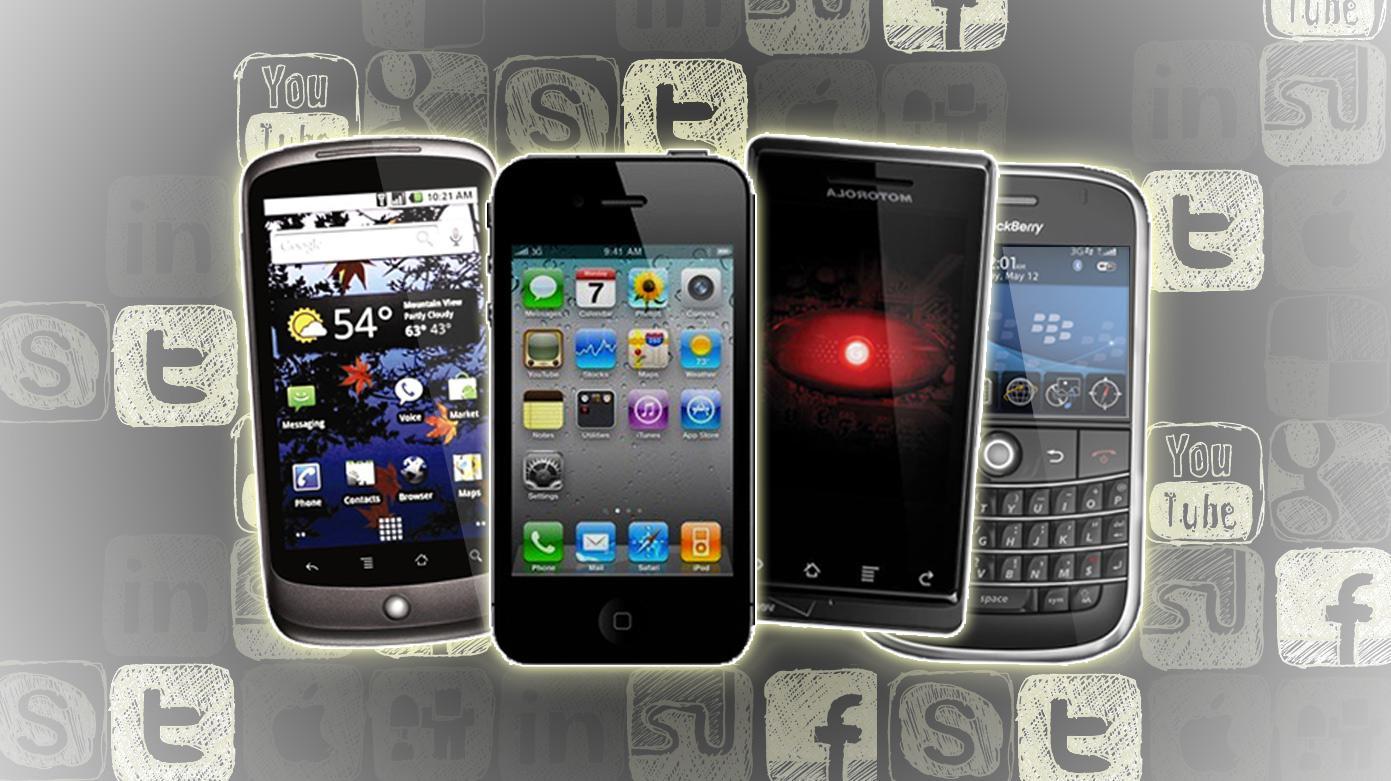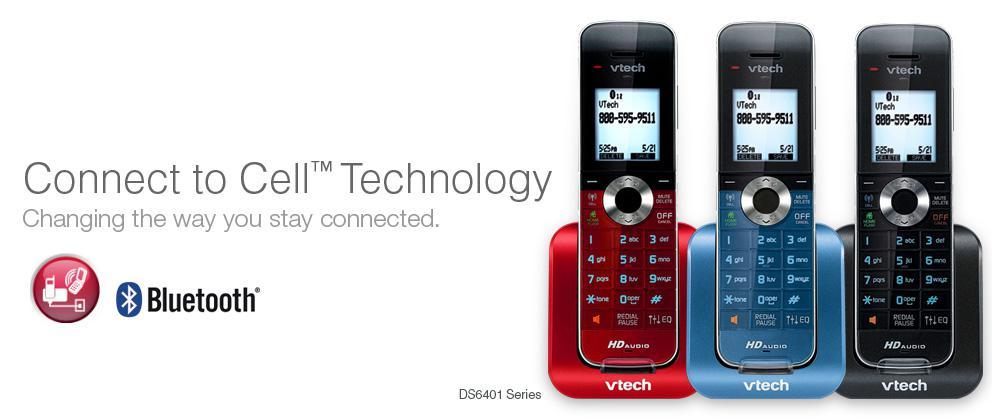The first image is the image on the left, the second image is the image on the right. Analyze the images presented: Is the assertion "There is a non smart phone in a charger." valid? Answer yes or no. Yes. The first image is the image on the left, the second image is the image on the right. Evaluate the accuracy of this statement regarding the images: "The right image contains no more than three cell phones.". Is it true? Answer yes or no. Yes. 